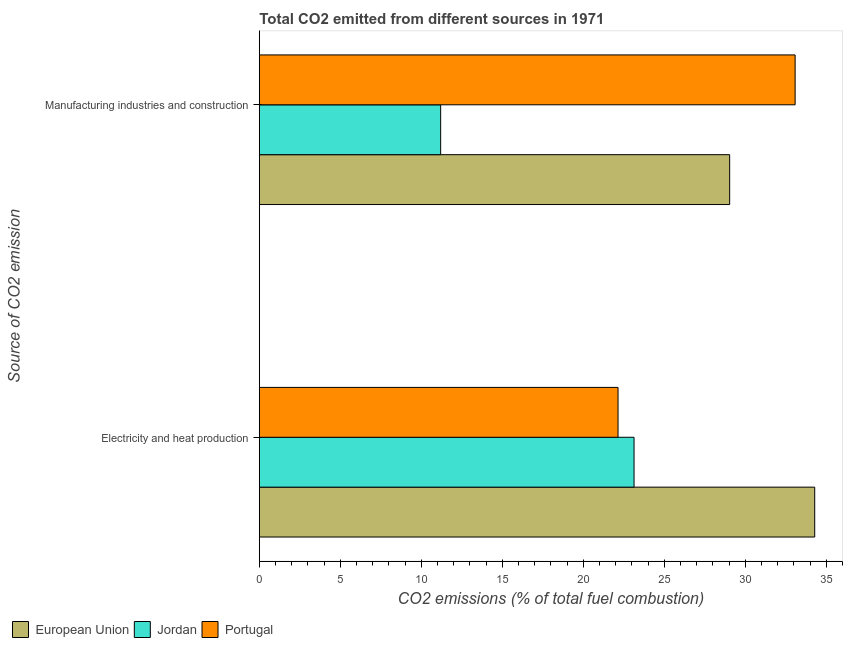How many different coloured bars are there?
Your answer should be compact. 3. How many groups of bars are there?
Your answer should be compact. 2. How many bars are there on the 2nd tick from the top?
Offer a terse response. 3. What is the label of the 2nd group of bars from the top?
Keep it short and to the point. Electricity and heat production. What is the co2 emissions due to electricity and heat production in Portugal?
Your answer should be compact. 22.15. Across all countries, what is the maximum co2 emissions due to manufacturing industries?
Make the answer very short. 33.08. Across all countries, what is the minimum co2 emissions due to manufacturing industries?
Provide a short and direct response. 11.19. In which country was the co2 emissions due to electricity and heat production maximum?
Provide a succinct answer. European Union. In which country was the co2 emissions due to manufacturing industries minimum?
Give a very brief answer. Jordan. What is the total co2 emissions due to manufacturing industries in the graph?
Keep it short and to the point. 73.31. What is the difference between the co2 emissions due to manufacturing industries in Portugal and that in Jordan?
Offer a terse response. 21.89. What is the difference between the co2 emissions due to manufacturing industries in Portugal and the co2 emissions due to electricity and heat production in European Union?
Offer a very short reply. -1.21. What is the average co2 emissions due to manufacturing industries per country?
Your response must be concise. 24.44. What is the difference between the co2 emissions due to electricity and heat production and co2 emissions due to manufacturing industries in Jordan?
Offer a very short reply. 11.94. What is the ratio of the co2 emissions due to manufacturing industries in European Union to that in Portugal?
Offer a very short reply. 0.88. Is the co2 emissions due to electricity and heat production in Jordan less than that in European Union?
Keep it short and to the point. Yes. In how many countries, is the co2 emissions due to electricity and heat production greater than the average co2 emissions due to electricity and heat production taken over all countries?
Ensure brevity in your answer.  1. What does the 3rd bar from the top in Manufacturing industries and construction represents?
Your answer should be compact. European Union. What does the 2nd bar from the bottom in Electricity and heat production represents?
Give a very brief answer. Jordan. How many bars are there?
Offer a very short reply. 6. Are all the bars in the graph horizontal?
Your response must be concise. Yes. How many countries are there in the graph?
Make the answer very short. 3. Are the values on the major ticks of X-axis written in scientific E-notation?
Keep it short and to the point. No. Where does the legend appear in the graph?
Make the answer very short. Bottom left. How are the legend labels stacked?
Your answer should be compact. Horizontal. What is the title of the graph?
Your answer should be very brief. Total CO2 emitted from different sources in 1971. Does "Timor-Leste" appear as one of the legend labels in the graph?
Keep it short and to the point. No. What is the label or title of the X-axis?
Make the answer very short. CO2 emissions (% of total fuel combustion). What is the label or title of the Y-axis?
Provide a short and direct response. Source of CO2 emission. What is the CO2 emissions (% of total fuel combustion) in European Union in Electricity and heat production?
Your answer should be compact. 34.29. What is the CO2 emissions (% of total fuel combustion) in Jordan in Electricity and heat production?
Your answer should be compact. 23.13. What is the CO2 emissions (% of total fuel combustion) of Portugal in Electricity and heat production?
Your answer should be very brief. 22.15. What is the CO2 emissions (% of total fuel combustion) in European Union in Manufacturing industries and construction?
Your response must be concise. 29.04. What is the CO2 emissions (% of total fuel combustion) of Jordan in Manufacturing industries and construction?
Your answer should be very brief. 11.19. What is the CO2 emissions (% of total fuel combustion) in Portugal in Manufacturing industries and construction?
Your response must be concise. 33.08. Across all Source of CO2 emission, what is the maximum CO2 emissions (% of total fuel combustion) of European Union?
Make the answer very short. 34.29. Across all Source of CO2 emission, what is the maximum CO2 emissions (% of total fuel combustion) of Jordan?
Your answer should be compact. 23.13. Across all Source of CO2 emission, what is the maximum CO2 emissions (% of total fuel combustion) of Portugal?
Your answer should be very brief. 33.08. Across all Source of CO2 emission, what is the minimum CO2 emissions (% of total fuel combustion) of European Union?
Provide a short and direct response. 29.04. Across all Source of CO2 emission, what is the minimum CO2 emissions (% of total fuel combustion) of Jordan?
Provide a succinct answer. 11.19. Across all Source of CO2 emission, what is the minimum CO2 emissions (% of total fuel combustion) of Portugal?
Your response must be concise. 22.15. What is the total CO2 emissions (% of total fuel combustion) of European Union in the graph?
Ensure brevity in your answer.  63.33. What is the total CO2 emissions (% of total fuel combustion) in Jordan in the graph?
Provide a succinct answer. 34.33. What is the total CO2 emissions (% of total fuel combustion) in Portugal in the graph?
Offer a very short reply. 55.22. What is the difference between the CO2 emissions (% of total fuel combustion) in European Union in Electricity and heat production and that in Manufacturing industries and construction?
Give a very brief answer. 5.25. What is the difference between the CO2 emissions (% of total fuel combustion) in Jordan in Electricity and heat production and that in Manufacturing industries and construction?
Provide a succinct answer. 11.94. What is the difference between the CO2 emissions (% of total fuel combustion) of Portugal in Electricity and heat production and that in Manufacturing industries and construction?
Provide a short and direct response. -10.93. What is the difference between the CO2 emissions (% of total fuel combustion) in European Union in Electricity and heat production and the CO2 emissions (% of total fuel combustion) in Jordan in Manufacturing industries and construction?
Your answer should be compact. 23.1. What is the difference between the CO2 emissions (% of total fuel combustion) of European Union in Electricity and heat production and the CO2 emissions (% of total fuel combustion) of Portugal in Manufacturing industries and construction?
Give a very brief answer. 1.21. What is the difference between the CO2 emissions (% of total fuel combustion) in Jordan in Electricity and heat production and the CO2 emissions (% of total fuel combustion) in Portugal in Manufacturing industries and construction?
Ensure brevity in your answer.  -9.95. What is the average CO2 emissions (% of total fuel combustion) of European Union per Source of CO2 emission?
Your answer should be very brief. 31.66. What is the average CO2 emissions (% of total fuel combustion) in Jordan per Source of CO2 emission?
Provide a succinct answer. 17.16. What is the average CO2 emissions (% of total fuel combustion) in Portugal per Source of CO2 emission?
Offer a very short reply. 27.61. What is the difference between the CO2 emissions (% of total fuel combustion) in European Union and CO2 emissions (% of total fuel combustion) in Jordan in Electricity and heat production?
Provide a short and direct response. 11.15. What is the difference between the CO2 emissions (% of total fuel combustion) in European Union and CO2 emissions (% of total fuel combustion) in Portugal in Electricity and heat production?
Offer a very short reply. 12.14. What is the difference between the CO2 emissions (% of total fuel combustion) of Jordan and CO2 emissions (% of total fuel combustion) of Portugal in Electricity and heat production?
Offer a very short reply. 0.99. What is the difference between the CO2 emissions (% of total fuel combustion) of European Union and CO2 emissions (% of total fuel combustion) of Jordan in Manufacturing industries and construction?
Your response must be concise. 17.84. What is the difference between the CO2 emissions (% of total fuel combustion) in European Union and CO2 emissions (% of total fuel combustion) in Portugal in Manufacturing industries and construction?
Offer a terse response. -4.04. What is the difference between the CO2 emissions (% of total fuel combustion) of Jordan and CO2 emissions (% of total fuel combustion) of Portugal in Manufacturing industries and construction?
Provide a succinct answer. -21.89. What is the ratio of the CO2 emissions (% of total fuel combustion) in European Union in Electricity and heat production to that in Manufacturing industries and construction?
Offer a terse response. 1.18. What is the ratio of the CO2 emissions (% of total fuel combustion) of Jordan in Electricity and heat production to that in Manufacturing industries and construction?
Offer a very short reply. 2.07. What is the ratio of the CO2 emissions (% of total fuel combustion) of Portugal in Electricity and heat production to that in Manufacturing industries and construction?
Ensure brevity in your answer.  0.67. What is the difference between the highest and the second highest CO2 emissions (% of total fuel combustion) of European Union?
Offer a very short reply. 5.25. What is the difference between the highest and the second highest CO2 emissions (% of total fuel combustion) in Jordan?
Give a very brief answer. 11.94. What is the difference between the highest and the second highest CO2 emissions (% of total fuel combustion) of Portugal?
Your response must be concise. 10.93. What is the difference between the highest and the lowest CO2 emissions (% of total fuel combustion) of European Union?
Provide a succinct answer. 5.25. What is the difference between the highest and the lowest CO2 emissions (% of total fuel combustion) of Jordan?
Ensure brevity in your answer.  11.94. What is the difference between the highest and the lowest CO2 emissions (% of total fuel combustion) in Portugal?
Offer a very short reply. 10.93. 